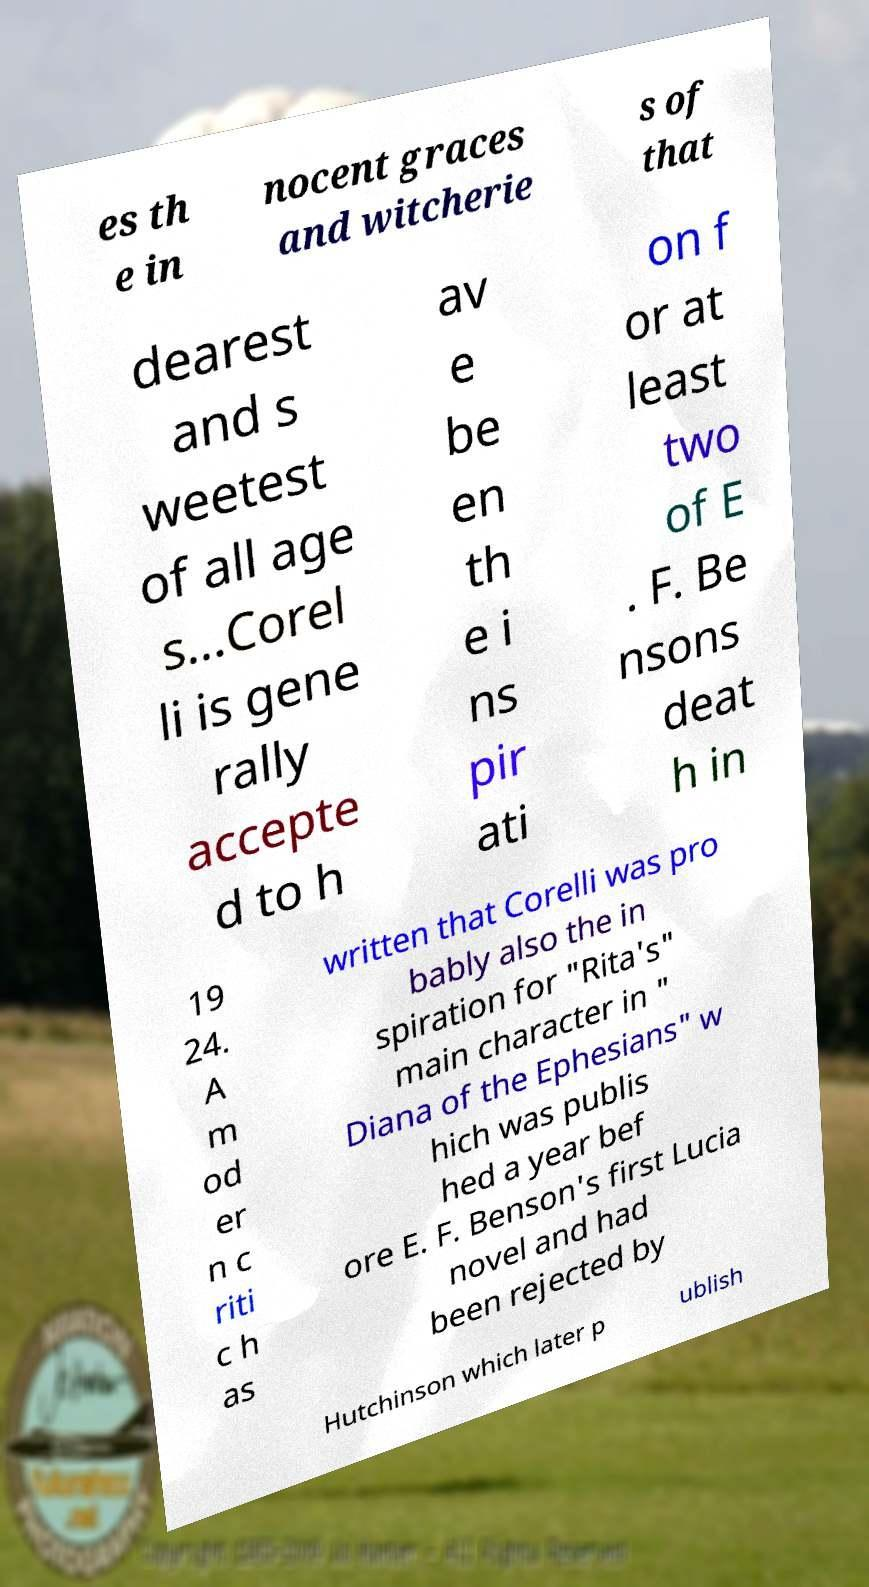What messages or text are displayed in this image? I need them in a readable, typed format. es th e in nocent graces and witcherie s of that dearest and s weetest of all age s...Corel li is gene rally accepte d to h av e be en th e i ns pir ati on f or at least two of E . F. Be nsons deat h in 19 24. A m od er n c riti c h as written that Corelli was pro bably also the in spiration for "Rita's" main character in " Diana of the Ephesians" w hich was publis hed a year bef ore E. F. Benson's first Lucia novel and had been rejected by Hutchinson which later p ublish 